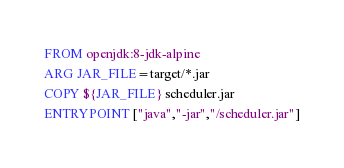<code> <loc_0><loc_0><loc_500><loc_500><_Dockerfile_>FROM openjdk:8-jdk-alpine
ARG JAR_FILE=target/*.jar
COPY ${JAR_FILE} scheduler.jar
ENTRYPOINT ["java","-jar","/scheduler.jar"]
</code> 